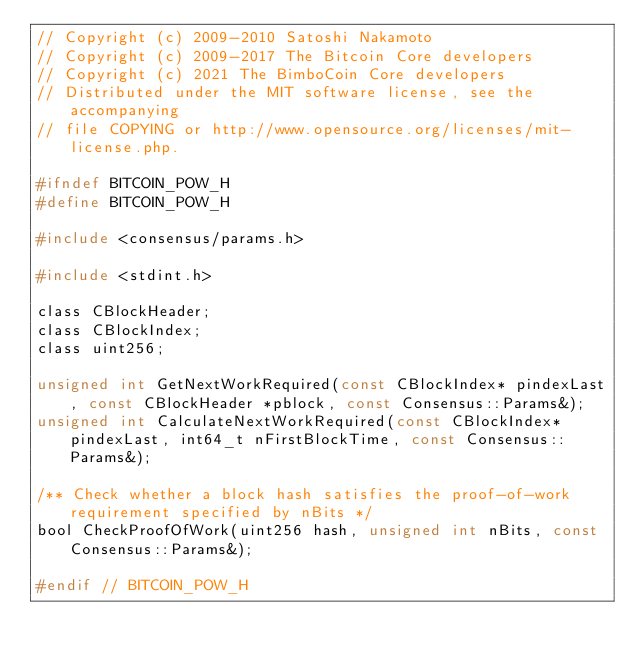<code> <loc_0><loc_0><loc_500><loc_500><_C_>// Copyright (c) 2009-2010 Satoshi Nakamoto
// Copyright (c) 2009-2017 The Bitcoin Core developers
// Copyright (c) 2021 The BimboCoin Core developers
// Distributed under the MIT software license, see the accompanying
// file COPYING or http://www.opensource.org/licenses/mit-license.php.

#ifndef BITCOIN_POW_H
#define BITCOIN_POW_H

#include <consensus/params.h>

#include <stdint.h>

class CBlockHeader;
class CBlockIndex;
class uint256;

unsigned int GetNextWorkRequired(const CBlockIndex* pindexLast, const CBlockHeader *pblock, const Consensus::Params&);
unsigned int CalculateNextWorkRequired(const CBlockIndex* pindexLast, int64_t nFirstBlockTime, const Consensus::Params&);

/** Check whether a block hash satisfies the proof-of-work requirement specified by nBits */
bool CheckProofOfWork(uint256 hash, unsigned int nBits, const Consensus::Params&);

#endif // BITCOIN_POW_H
</code> 